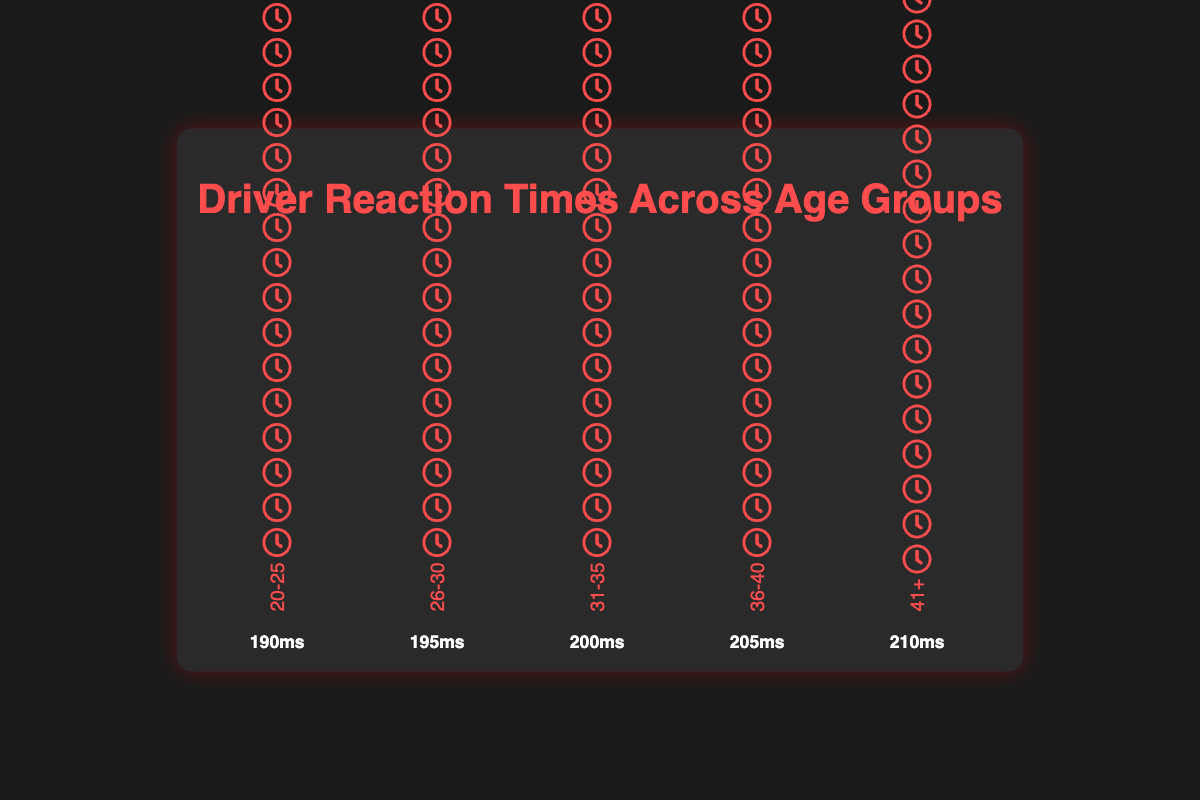What is the reaction time for the age group 31-35? The reaction time value is given at the bottom of the group labeled "31-35"
Answer: 200ms Which age group has the fastest reaction time? The age group with the lowest reaction time is the one labeled "20-25" with a reaction time of 190ms
Answer: 20-25 How many drivers are represented in the age group 41+? The count of individual icons in the age group labeled "41+" represents the number of drivers. Each icon represents one driver.
Answer: 2 What is the difference in reaction times between the age groups 26-30 and 36-40? The reaction time for 26-30 is 195ms and for 36-40 is 205ms. The difference can be calculated as 205ms - 195ms
Answer: 10ms What is the average reaction time across all age groups? Sum the reaction times for all groups and divide by the number of groups: (190 + 195 + 200 + 205 + 210) / 5 = 1000 / 5
Answer: 200ms Which age group has the most drivers represented? Count the icons in each age group. The group with the most icons is "20-25" with 3 drivers.
Answer: 20-25 Compare the reaction times of age groups 36-40 and 41+. Which one is slower? The reaction time for 36-40 is 205ms and for 41+ is 210ms. Since 210ms > 205ms, 41+ is slower.
Answer: 41+ In terms of reaction times, which age groups have a difference of exactly 5ms between them? Compare the difference in reaction times for each group pair. The pair with a 5ms difference is 26-30 (195ms) and 31-35 (200ms).
Answer: 26-30 and 31-35 What is the sum of reaction times for the age groups 20-25 and 31-35? Add the reaction times for 20-25 (190ms) and 31-35 (200ms): 190ms + 200ms
Answer: 390ms Identify two drivers from the age groups with the fastest and slowest reaction times. The fastest reaction time corresponds to 20-25 (Max Verstappen, Lando Norris, Lance Stroll) and the slowest to 41+ (Fernando Alonso, Kimi Raikkonen). Therefore, one driver from each could be: Max Verstappen and Kimi Raikkonen
Answer: Max Verstappen and Kimi Raikkonen 